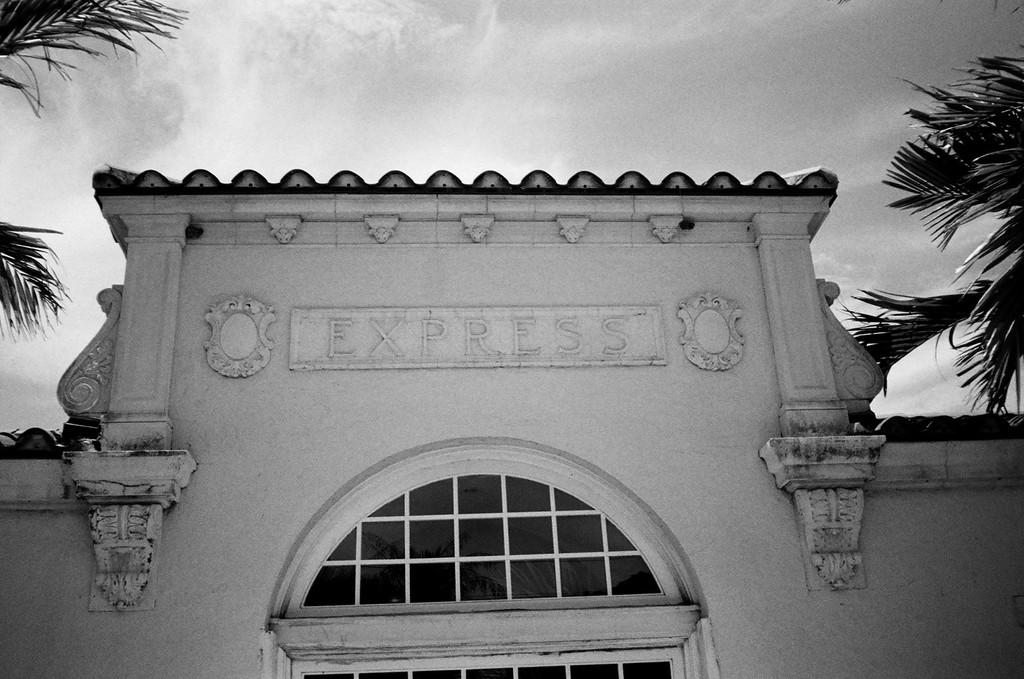What is the color scheme of the image? The image is black and white. What type of structure can be seen in the image? There is a building in the image. Where are the coconut trees located in the image? There are coconut trees on both the right and left sides of the image. What can be seen in the background of the image? The sky is visible in the background of the image. What type of education is being taught in the image? There is no indication of any educational activity in the image; it primarily features a building, coconut trees, and the sky. Can you hear a whistle in the image? There is no audible sound in the image, so it is impossible to determine if a whistle can be heard. 